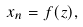Convert formula to latex. <formula><loc_0><loc_0><loc_500><loc_500>x _ { n } = f ( z ) ,</formula> 